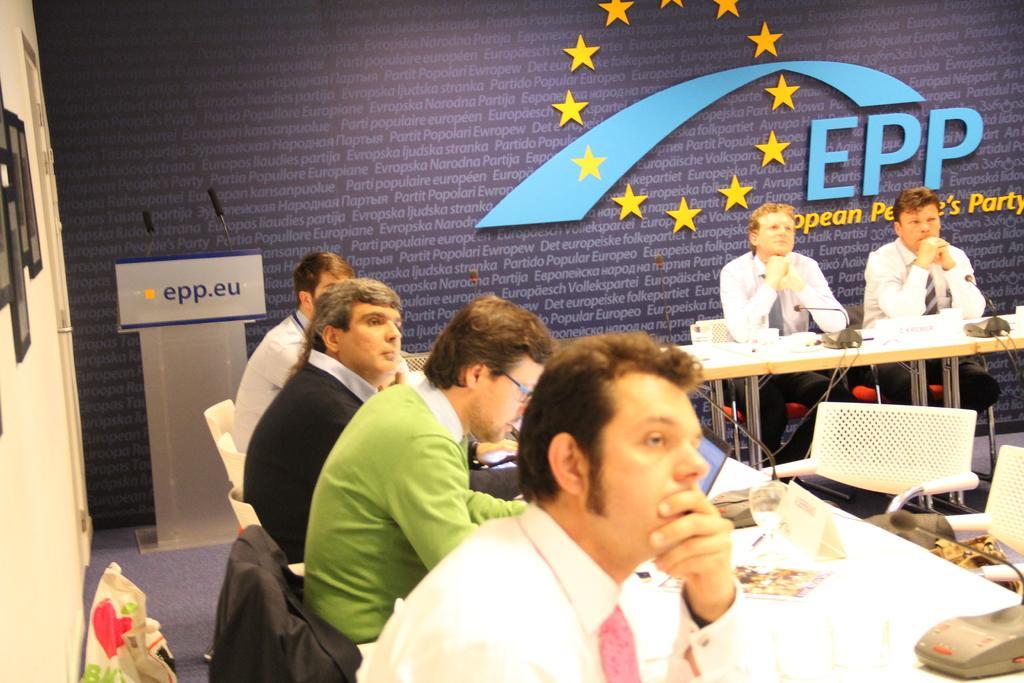In one or two sentences, can you explain what this image depicts? In this image we can see a group of people sitting in chairs placed in front of a table. One person is wearing spectacles and a green t shirt. On the table we can see a group of microphones and a laptop are placed. To the left side of the image we can see a podium with two microphone ad photo frames on the wall. In the background we can see a wall with some text on it. 